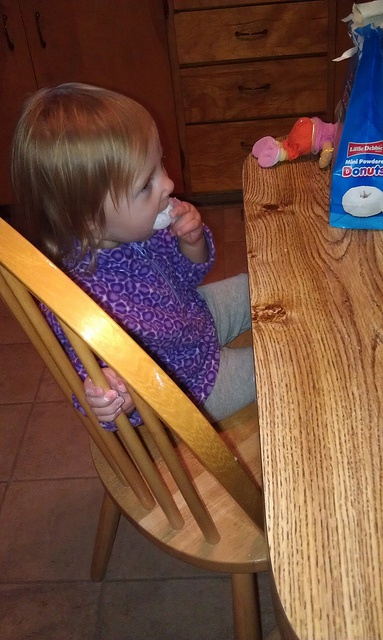Describe the objects in this image and their specific colors. I can see dining table in black, brown, and tan tones, people in black, maroon, gray, and navy tones, chair in black, maroon, brown, and gray tones, donut in black, darkgray, and lightgray tones, and donut in black, darkgray, and gray tones in this image. 